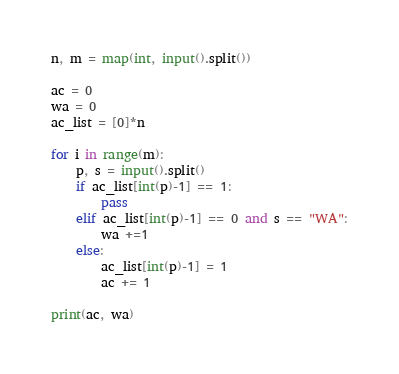Convert code to text. <code><loc_0><loc_0><loc_500><loc_500><_Python_>n, m = map(int, input().split())

ac = 0
wa = 0
ac_list = [0]*n

for i in range(m):
    p, s = input().split()
    if ac_list[int(p)-1] == 1:
        pass
    elif ac_list[int(p)-1] == 0 and s == "WA":
        wa +=1
    else:
        ac_list[int(p)-1] = 1
        ac += 1

print(ac, wa)</code> 